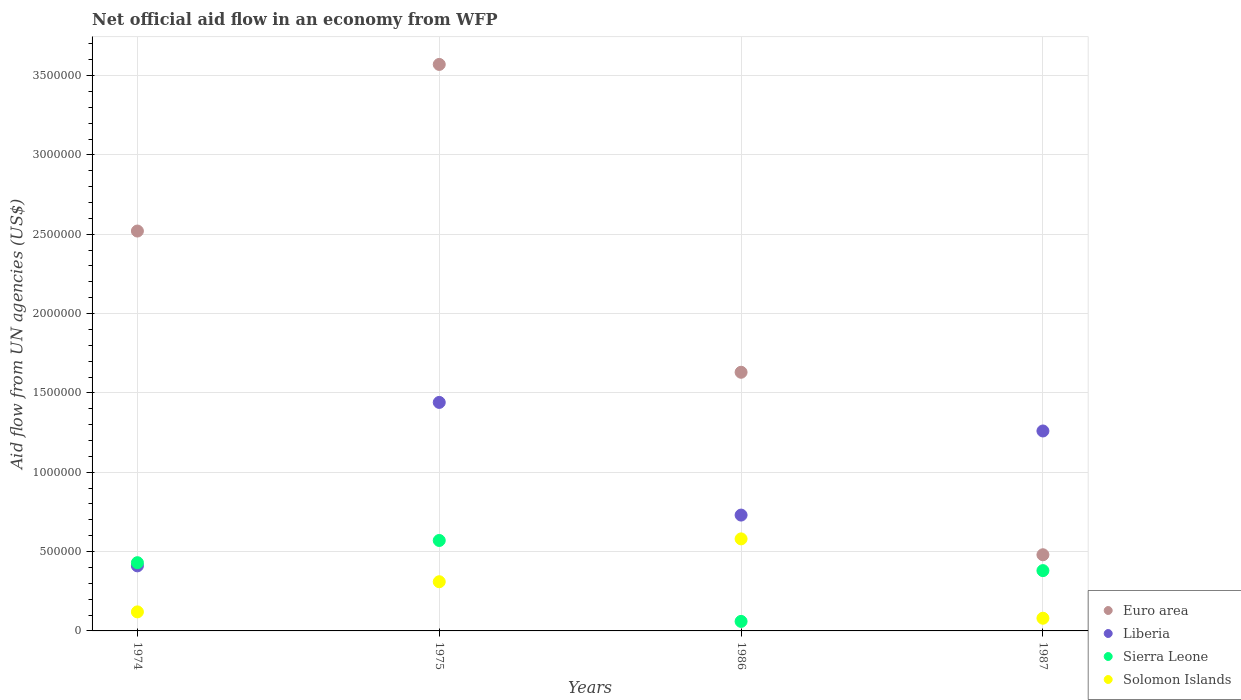Is the number of dotlines equal to the number of legend labels?
Give a very brief answer. Yes. What is the net official aid flow in Sierra Leone in 1987?
Your answer should be very brief. 3.80e+05. Across all years, what is the maximum net official aid flow in Sierra Leone?
Keep it short and to the point. 5.70e+05. Across all years, what is the minimum net official aid flow in Euro area?
Keep it short and to the point. 4.80e+05. In which year was the net official aid flow in Liberia maximum?
Keep it short and to the point. 1975. In which year was the net official aid flow in Sierra Leone minimum?
Keep it short and to the point. 1986. What is the total net official aid flow in Solomon Islands in the graph?
Provide a short and direct response. 1.09e+06. What is the difference between the net official aid flow in Liberia in 1974 and that in 1986?
Offer a very short reply. -3.20e+05. What is the difference between the net official aid flow in Sierra Leone in 1974 and the net official aid flow in Liberia in 1987?
Your response must be concise. -8.30e+05. What is the average net official aid flow in Liberia per year?
Offer a terse response. 9.60e+05. In the year 1986, what is the difference between the net official aid flow in Sierra Leone and net official aid flow in Solomon Islands?
Offer a very short reply. -5.20e+05. What is the ratio of the net official aid flow in Liberia in 1975 to that in 1987?
Provide a succinct answer. 1.14. Is the difference between the net official aid flow in Sierra Leone in 1974 and 1975 greater than the difference between the net official aid flow in Solomon Islands in 1974 and 1975?
Offer a very short reply. Yes. What is the difference between the highest and the second highest net official aid flow in Euro area?
Your answer should be very brief. 1.05e+06. What is the difference between the highest and the lowest net official aid flow in Solomon Islands?
Your answer should be very brief. 5.00e+05. Is the sum of the net official aid flow in Liberia in 1974 and 1987 greater than the maximum net official aid flow in Euro area across all years?
Provide a succinct answer. No. Is it the case that in every year, the sum of the net official aid flow in Sierra Leone and net official aid flow in Euro area  is greater than the net official aid flow in Liberia?
Your answer should be very brief. No. Is the net official aid flow in Solomon Islands strictly less than the net official aid flow in Sierra Leone over the years?
Your answer should be very brief. No. How many dotlines are there?
Your answer should be very brief. 4. Does the graph contain grids?
Ensure brevity in your answer.  Yes. Where does the legend appear in the graph?
Make the answer very short. Bottom right. How many legend labels are there?
Your response must be concise. 4. How are the legend labels stacked?
Your answer should be compact. Vertical. What is the title of the graph?
Offer a terse response. Net official aid flow in an economy from WFP. What is the label or title of the Y-axis?
Make the answer very short. Aid flow from UN agencies (US$). What is the Aid flow from UN agencies (US$) of Euro area in 1974?
Provide a short and direct response. 2.52e+06. What is the Aid flow from UN agencies (US$) in Solomon Islands in 1974?
Offer a very short reply. 1.20e+05. What is the Aid flow from UN agencies (US$) of Euro area in 1975?
Your response must be concise. 3.57e+06. What is the Aid flow from UN agencies (US$) in Liberia in 1975?
Provide a succinct answer. 1.44e+06. What is the Aid flow from UN agencies (US$) of Sierra Leone in 1975?
Offer a very short reply. 5.70e+05. What is the Aid flow from UN agencies (US$) of Euro area in 1986?
Give a very brief answer. 1.63e+06. What is the Aid flow from UN agencies (US$) of Liberia in 1986?
Keep it short and to the point. 7.30e+05. What is the Aid flow from UN agencies (US$) of Solomon Islands in 1986?
Give a very brief answer. 5.80e+05. What is the Aid flow from UN agencies (US$) of Liberia in 1987?
Offer a terse response. 1.26e+06. What is the Aid flow from UN agencies (US$) of Sierra Leone in 1987?
Keep it short and to the point. 3.80e+05. Across all years, what is the maximum Aid flow from UN agencies (US$) in Euro area?
Give a very brief answer. 3.57e+06. Across all years, what is the maximum Aid flow from UN agencies (US$) of Liberia?
Your response must be concise. 1.44e+06. Across all years, what is the maximum Aid flow from UN agencies (US$) in Sierra Leone?
Provide a succinct answer. 5.70e+05. Across all years, what is the maximum Aid flow from UN agencies (US$) of Solomon Islands?
Your response must be concise. 5.80e+05. Across all years, what is the minimum Aid flow from UN agencies (US$) in Liberia?
Offer a terse response. 4.10e+05. Across all years, what is the minimum Aid flow from UN agencies (US$) in Sierra Leone?
Your answer should be compact. 6.00e+04. Across all years, what is the minimum Aid flow from UN agencies (US$) of Solomon Islands?
Your answer should be compact. 8.00e+04. What is the total Aid flow from UN agencies (US$) in Euro area in the graph?
Give a very brief answer. 8.20e+06. What is the total Aid flow from UN agencies (US$) in Liberia in the graph?
Give a very brief answer. 3.84e+06. What is the total Aid flow from UN agencies (US$) of Sierra Leone in the graph?
Your answer should be compact. 1.44e+06. What is the total Aid flow from UN agencies (US$) in Solomon Islands in the graph?
Give a very brief answer. 1.09e+06. What is the difference between the Aid flow from UN agencies (US$) in Euro area in 1974 and that in 1975?
Keep it short and to the point. -1.05e+06. What is the difference between the Aid flow from UN agencies (US$) in Liberia in 1974 and that in 1975?
Your response must be concise. -1.03e+06. What is the difference between the Aid flow from UN agencies (US$) in Euro area in 1974 and that in 1986?
Offer a terse response. 8.90e+05. What is the difference between the Aid flow from UN agencies (US$) of Liberia in 1974 and that in 1986?
Ensure brevity in your answer.  -3.20e+05. What is the difference between the Aid flow from UN agencies (US$) of Solomon Islands in 1974 and that in 1986?
Offer a terse response. -4.60e+05. What is the difference between the Aid flow from UN agencies (US$) in Euro area in 1974 and that in 1987?
Offer a terse response. 2.04e+06. What is the difference between the Aid flow from UN agencies (US$) of Liberia in 1974 and that in 1987?
Ensure brevity in your answer.  -8.50e+05. What is the difference between the Aid flow from UN agencies (US$) of Solomon Islands in 1974 and that in 1987?
Offer a terse response. 4.00e+04. What is the difference between the Aid flow from UN agencies (US$) in Euro area in 1975 and that in 1986?
Make the answer very short. 1.94e+06. What is the difference between the Aid flow from UN agencies (US$) in Liberia in 1975 and that in 1986?
Offer a terse response. 7.10e+05. What is the difference between the Aid flow from UN agencies (US$) of Sierra Leone in 1975 and that in 1986?
Offer a terse response. 5.10e+05. What is the difference between the Aid flow from UN agencies (US$) in Solomon Islands in 1975 and that in 1986?
Ensure brevity in your answer.  -2.70e+05. What is the difference between the Aid flow from UN agencies (US$) of Euro area in 1975 and that in 1987?
Keep it short and to the point. 3.09e+06. What is the difference between the Aid flow from UN agencies (US$) in Liberia in 1975 and that in 1987?
Your answer should be compact. 1.80e+05. What is the difference between the Aid flow from UN agencies (US$) of Sierra Leone in 1975 and that in 1987?
Your answer should be very brief. 1.90e+05. What is the difference between the Aid flow from UN agencies (US$) of Euro area in 1986 and that in 1987?
Your answer should be very brief. 1.15e+06. What is the difference between the Aid flow from UN agencies (US$) in Liberia in 1986 and that in 1987?
Give a very brief answer. -5.30e+05. What is the difference between the Aid flow from UN agencies (US$) of Sierra Leone in 1986 and that in 1987?
Provide a succinct answer. -3.20e+05. What is the difference between the Aid flow from UN agencies (US$) in Euro area in 1974 and the Aid flow from UN agencies (US$) in Liberia in 1975?
Keep it short and to the point. 1.08e+06. What is the difference between the Aid flow from UN agencies (US$) in Euro area in 1974 and the Aid flow from UN agencies (US$) in Sierra Leone in 1975?
Your answer should be compact. 1.95e+06. What is the difference between the Aid flow from UN agencies (US$) in Euro area in 1974 and the Aid flow from UN agencies (US$) in Solomon Islands in 1975?
Give a very brief answer. 2.21e+06. What is the difference between the Aid flow from UN agencies (US$) of Sierra Leone in 1974 and the Aid flow from UN agencies (US$) of Solomon Islands in 1975?
Provide a succinct answer. 1.20e+05. What is the difference between the Aid flow from UN agencies (US$) in Euro area in 1974 and the Aid flow from UN agencies (US$) in Liberia in 1986?
Offer a terse response. 1.79e+06. What is the difference between the Aid flow from UN agencies (US$) in Euro area in 1974 and the Aid flow from UN agencies (US$) in Sierra Leone in 1986?
Make the answer very short. 2.46e+06. What is the difference between the Aid flow from UN agencies (US$) in Euro area in 1974 and the Aid flow from UN agencies (US$) in Solomon Islands in 1986?
Provide a short and direct response. 1.94e+06. What is the difference between the Aid flow from UN agencies (US$) in Liberia in 1974 and the Aid flow from UN agencies (US$) in Sierra Leone in 1986?
Keep it short and to the point. 3.50e+05. What is the difference between the Aid flow from UN agencies (US$) in Sierra Leone in 1974 and the Aid flow from UN agencies (US$) in Solomon Islands in 1986?
Your answer should be very brief. -1.50e+05. What is the difference between the Aid flow from UN agencies (US$) in Euro area in 1974 and the Aid flow from UN agencies (US$) in Liberia in 1987?
Provide a short and direct response. 1.26e+06. What is the difference between the Aid flow from UN agencies (US$) in Euro area in 1974 and the Aid flow from UN agencies (US$) in Sierra Leone in 1987?
Your answer should be very brief. 2.14e+06. What is the difference between the Aid flow from UN agencies (US$) of Euro area in 1974 and the Aid flow from UN agencies (US$) of Solomon Islands in 1987?
Give a very brief answer. 2.44e+06. What is the difference between the Aid flow from UN agencies (US$) in Liberia in 1974 and the Aid flow from UN agencies (US$) in Sierra Leone in 1987?
Ensure brevity in your answer.  3.00e+04. What is the difference between the Aid flow from UN agencies (US$) of Liberia in 1974 and the Aid flow from UN agencies (US$) of Solomon Islands in 1987?
Keep it short and to the point. 3.30e+05. What is the difference between the Aid flow from UN agencies (US$) in Sierra Leone in 1974 and the Aid flow from UN agencies (US$) in Solomon Islands in 1987?
Offer a terse response. 3.50e+05. What is the difference between the Aid flow from UN agencies (US$) in Euro area in 1975 and the Aid flow from UN agencies (US$) in Liberia in 1986?
Keep it short and to the point. 2.84e+06. What is the difference between the Aid flow from UN agencies (US$) of Euro area in 1975 and the Aid flow from UN agencies (US$) of Sierra Leone in 1986?
Your answer should be compact. 3.51e+06. What is the difference between the Aid flow from UN agencies (US$) of Euro area in 1975 and the Aid flow from UN agencies (US$) of Solomon Islands in 1986?
Give a very brief answer. 2.99e+06. What is the difference between the Aid flow from UN agencies (US$) in Liberia in 1975 and the Aid flow from UN agencies (US$) in Sierra Leone in 1986?
Your response must be concise. 1.38e+06. What is the difference between the Aid flow from UN agencies (US$) in Liberia in 1975 and the Aid flow from UN agencies (US$) in Solomon Islands in 1986?
Your answer should be compact. 8.60e+05. What is the difference between the Aid flow from UN agencies (US$) in Sierra Leone in 1975 and the Aid flow from UN agencies (US$) in Solomon Islands in 1986?
Provide a short and direct response. -10000. What is the difference between the Aid flow from UN agencies (US$) in Euro area in 1975 and the Aid flow from UN agencies (US$) in Liberia in 1987?
Ensure brevity in your answer.  2.31e+06. What is the difference between the Aid flow from UN agencies (US$) in Euro area in 1975 and the Aid flow from UN agencies (US$) in Sierra Leone in 1987?
Offer a very short reply. 3.19e+06. What is the difference between the Aid flow from UN agencies (US$) in Euro area in 1975 and the Aid flow from UN agencies (US$) in Solomon Islands in 1987?
Your answer should be compact. 3.49e+06. What is the difference between the Aid flow from UN agencies (US$) in Liberia in 1975 and the Aid flow from UN agencies (US$) in Sierra Leone in 1987?
Provide a short and direct response. 1.06e+06. What is the difference between the Aid flow from UN agencies (US$) of Liberia in 1975 and the Aid flow from UN agencies (US$) of Solomon Islands in 1987?
Offer a terse response. 1.36e+06. What is the difference between the Aid flow from UN agencies (US$) in Euro area in 1986 and the Aid flow from UN agencies (US$) in Liberia in 1987?
Give a very brief answer. 3.70e+05. What is the difference between the Aid flow from UN agencies (US$) in Euro area in 1986 and the Aid flow from UN agencies (US$) in Sierra Leone in 1987?
Give a very brief answer. 1.25e+06. What is the difference between the Aid flow from UN agencies (US$) of Euro area in 1986 and the Aid flow from UN agencies (US$) of Solomon Islands in 1987?
Provide a short and direct response. 1.55e+06. What is the difference between the Aid flow from UN agencies (US$) of Liberia in 1986 and the Aid flow from UN agencies (US$) of Solomon Islands in 1987?
Offer a terse response. 6.50e+05. What is the average Aid flow from UN agencies (US$) of Euro area per year?
Offer a terse response. 2.05e+06. What is the average Aid flow from UN agencies (US$) in Liberia per year?
Your answer should be very brief. 9.60e+05. What is the average Aid flow from UN agencies (US$) of Solomon Islands per year?
Make the answer very short. 2.72e+05. In the year 1974, what is the difference between the Aid flow from UN agencies (US$) of Euro area and Aid flow from UN agencies (US$) of Liberia?
Ensure brevity in your answer.  2.11e+06. In the year 1974, what is the difference between the Aid flow from UN agencies (US$) of Euro area and Aid flow from UN agencies (US$) of Sierra Leone?
Provide a short and direct response. 2.09e+06. In the year 1974, what is the difference between the Aid flow from UN agencies (US$) of Euro area and Aid flow from UN agencies (US$) of Solomon Islands?
Your answer should be compact. 2.40e+06. In the year 1974, what is the difference between the Aid flow from UN agencies (US$) of Liberia and Aid flow from UN agencies (US$) of Sierra Leone?
Provide a succinct answer. -2.00e+04. In the year 1974, what is the difference between the Aid flow from UN agencies (US$) in Liberia and Aid flow from UN agencies (US$) in Solomon Islands?
Provide a succinct answer. 2.90e+05. In the year 1974, what is the difference between the Aid flow from UN agencies (US$) in Sierra Leone and Aid flow from UN agencies (US$) in Solomon Islands?
Your response must be concise. 3.10e+05. In the year 1975, what is the difference between the Aid flow from UN agencies (US$) of Euro area and Aid flow from UN agencies (US$) of Liberia?
Your response must be concise. 2.13e+06. In the year 1975, what is the difference between the Aid flow from UN agencies (US$) of Euro area and Aid flow from UN agencies (US$) of Sierra Leone?
Your response must be concise. 3.00e+06. In the year 1975, what is the difference between the Aid flow from UN agencies (US$) of Euro area and Aid flow from UN agencies (US$) of Solomon Islands?
Ensure brevity in your answer.  3.26e+06. In the year 1975, what is the difference between the Aid flow from UN agencies (US$) of Liberia and Aid flow from UN agencies (US$) of Sierra Leone?
Make the answer very short. 8.70e+05. In the year 1975, what is the difference between the Aid flow from UN agencies (US$) in Liberia and Aid flow from UN agencies (US$) in Solomon Islands?
Offer a very short reply. 1.13e+06. In the year 1986, what is the difference between the Aid flow from UN agencies (US$) in Euro area and Aid flow from UN agencies (US$) in Liberia?
Ensure brevity in your answer.  9.00e+05. In the year 1986, what is the difference between the Aid flow from UN agencies (US$) of Euro area and Aid flow from UN agencies (US$) of Sierra Leone?
Ensure brevity in your answer.  1.57e+06. In the year 1986, what is the difference between the Aid flow from UN agencies (US$) in Euro area and Aid flow from UN agencies (US$) in Solomon Islands?
Provide a short and direct response. 1.05e+06. In the year 1986, what is the difference between the Aid flow from UN agencies (US$) of Liberia and Aid flow from UN agencies (US$) of Sierra Leone?
Ensure brevity in your answer.  6.70e+05. In the year 1986, what is the difference between the Aid flow from UN agencies (US$) of Sierra Leone and Aid flow from UN agencies (US$) of Solomon Islands?
Give a very brief answer. -5.20e+05. In the year 1987, what is the difference between the Aid flow from UN agencies (US$) of Euro area and Aid flow from UN agencies (US$) of Liberia?
Offer a very short reply. -7.80e+05. In the year 1987, what is the difference between the Aid flow from UN agencies (US$) of Euro area and Aid flow from UN agencies (US$) of Sierra Leone?
Your response must be concise. 1.00e+05. In the year 1987, what is the difference between the Aid flow from UN agencies (US$) of Liberia and Aid flow from UN agencies (US$) of Sierra Leone?
Ensure brevity in your answer.  8.80e+05. In the year 1987, what is the difference between the Aid flow from UN agencies (US$) of Liberia and Aid flow from UN agencies (US$) of Solomon Islands?
Your answer should be compact. 1.18e+06. In the year 1987, what is the difference between the Aid flow from UN agencies (US$) of Sierra Leone and Aid flow from UN agencies (US$) of Solomon Islands?
Keep it short and to the point. 3.00e+05. What is the ratio of the Aid flow from UN agencies (US$) in Euro area in 1974 to that in 1975?
Ensure brevity in your answer.  0.71. What is the ratio of the Aid flow from UN agencies (US$) of Liberia in 1974 to that in 1975?
Ensure brevity in your answer.  0.28. What is the ratio of the Aid flow from UN agencies (US$) of Sierra Leone in 1974 to that in 1975?
Provide a succinct answer. 0.75. What is the ratio of the Aid flow from UN agencies (US$) of Solomon Islands in 1974 to that in 1975?
Provide a succinct answer. 0.39. What is the ratio of the Aid flow from UN agencies (US$) of Euro area in 1974 to that in 1986?
Provide a succinct answer. 1.55. What is the ratio of the Aid flow from UN agencies (US$) in Liberia in 1974 to that in 1986?
Ensure brevity in your answer.  0.56. What is the ratio of the Aid flow from UN agencies (US$) of Sierra Leone in 1974 to that in 1986?
Offer a very short reply. 7.17. What is the ratio of the Aid flow from UN agencies (US$) of Solomon Islands in 1974 to that in 1986?
Make the answer very short. 0.21. What is the ratio of the Aid flow from UN agencies (US$) in Euro area in 1974 to that in 1987?
Give a very brief answer. 5.25. What is the ratio of the Aid flow from UN agencies (US$) in Liberia in 1974 to that in 1987?
Your response must be concise. 0.33. What is the ratio of the Aid flow from UN agencies (US$) in Sierra Leone in 1974 to that in 1987?
Provide a succinct answer. 1.13. What is the ratio of the Aid flow from UN agencies (US$) in Euro area in 1975 to that in 1986?
Your response must be concise. 2.19. What is the ratio of the Aid flow from UN agencies (US$) in Liberia in 1975 to that in 1986?
Keep it short and to the point. 1.97. What is the ratio of the Aid flow from UN agencies (US$) of Solomon Islands in 1975 to that in 1986?
Your response must be concise. 0.53. What is the ratio of the Aid flow from UN agencies (US$) in Euro area in 1975 to that in 1987?
Offer a terse response. 7.44. What is the ratio of the Aid flow from UN agencies (US$) in Liberia in 1975 to that in 1987?
Give a very brief answer. 1.14. What is the ratio of the Aid flow from UN agencies (US$) in Solomon Islands in 1975 to that in 1987?
Make the answer very short. 3.88. What is the ratio of the Aid flow from UN agencies (US$) in Euro area in 1986 to that in 1987?
Provide a succinct answer. 3.4. What is the ratio of the Aid flow from UN agencies (US$) of Liberia in 1986 to that in 1987?
Make the answer very short. 0.58. What is the ratio of the Aid flow from UN agencies (US$) in Sierra Leone in 1986 to that in 1987?
Give a very brief answer. 0.16. What is the ratio of the Aid flow from UN agencies (US$) of Solomon Islands in 1986 to that in 1987?
Your answer should be very brief. 7.25. What is the difference between the highest and the second highest Aid flow from UN agencies (US$) of Euro area?
Ensure brevity in your answer.  1.05e+06. What is the difference between the highest and the second highest Aid flow from UN agencies (US$) of Solomon Islands?
Offer a terse response. 2.70e+05. What is the difference between the highest and the lowest Aid flow from UN agencies (US$) in Euro area?
Provide a succinct answer. 3.09e+06. What is the difference between the highest and the lowest Aid flow from UN agencies (US$) in Liberia?
Offer a very short reply. 1.03e+06. What is the difference between the highest and the lowest Aid flow from UN agencies (US$) of Sierra Leone?
Provide a succinct answer. 5.10e+05. 